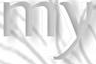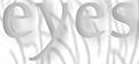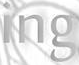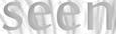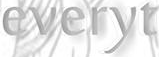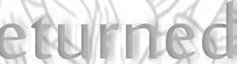Read the text content from these images in order, separated by a semicolon. my; eyes; ing; seen; everyt; eturned 